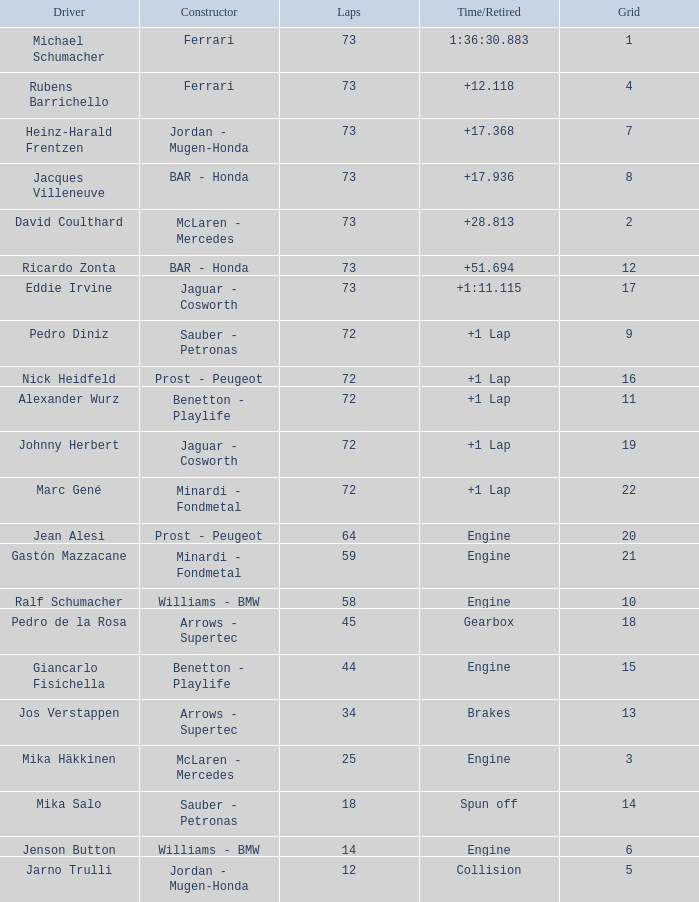With a grid of more than 15 cars, what was the total number of laps giancarlo fisichella finished? 0.0. 